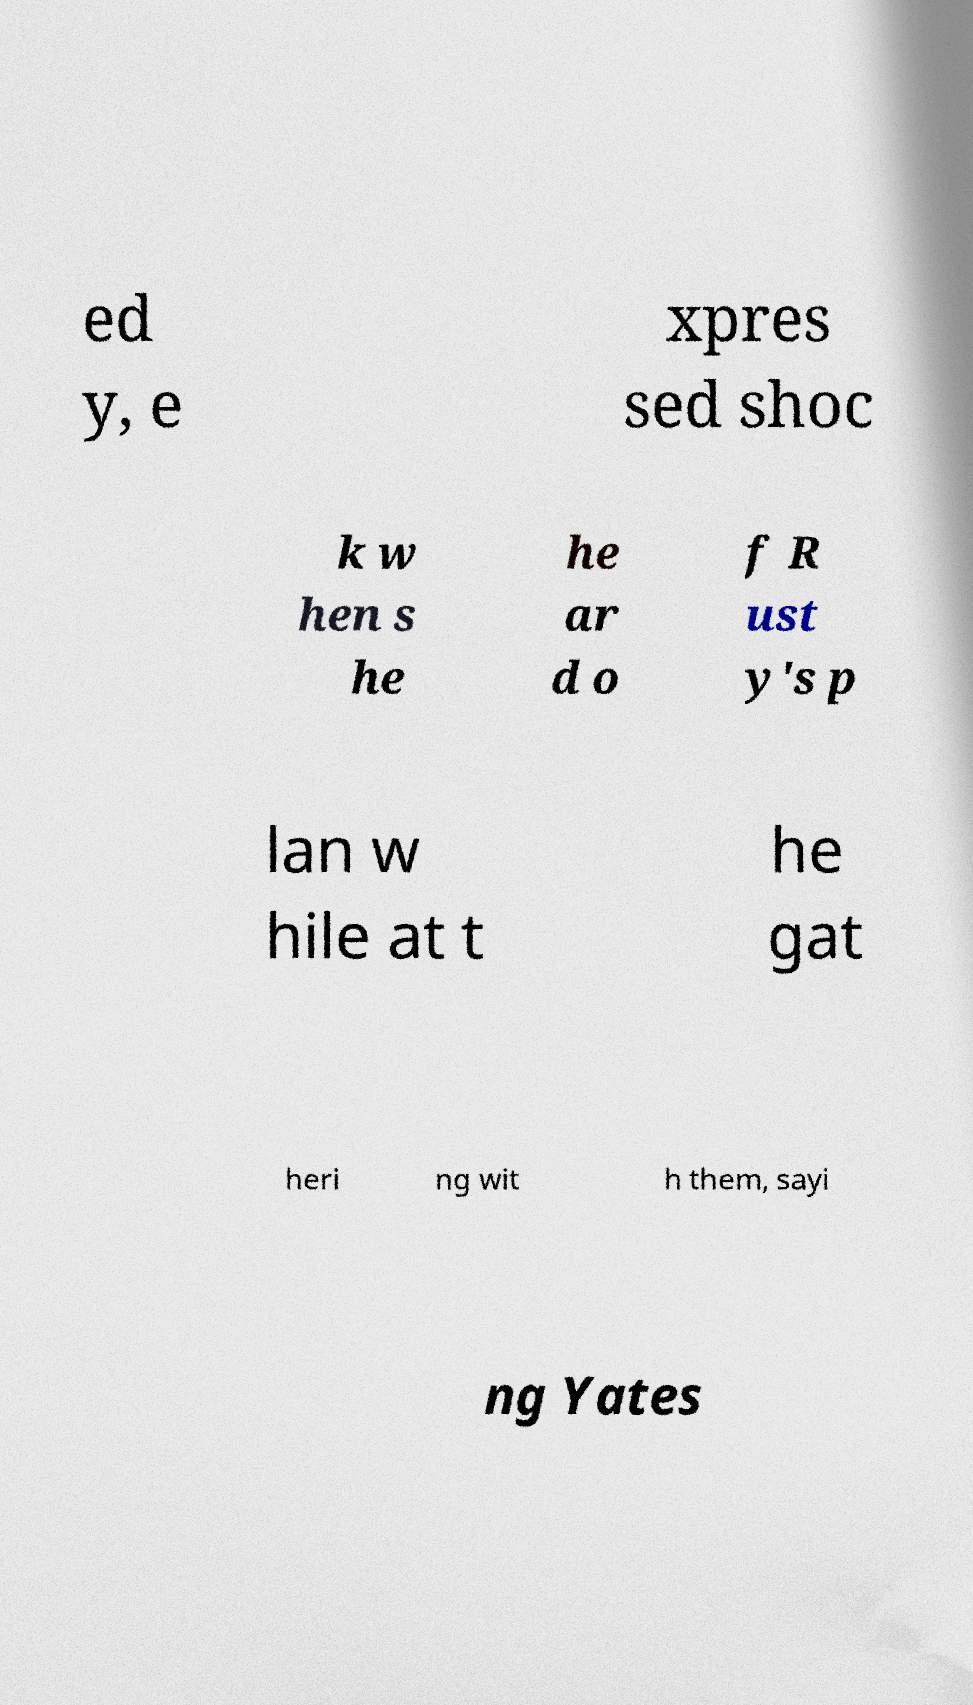What messages or text are displayed in this image? I need them in a readable, typed format. ed y, e xpres sed shoc k w hen s he he ar d o f R ust y's p lan w hile at t he gat heri ng wit h them, sayi ng Yates 